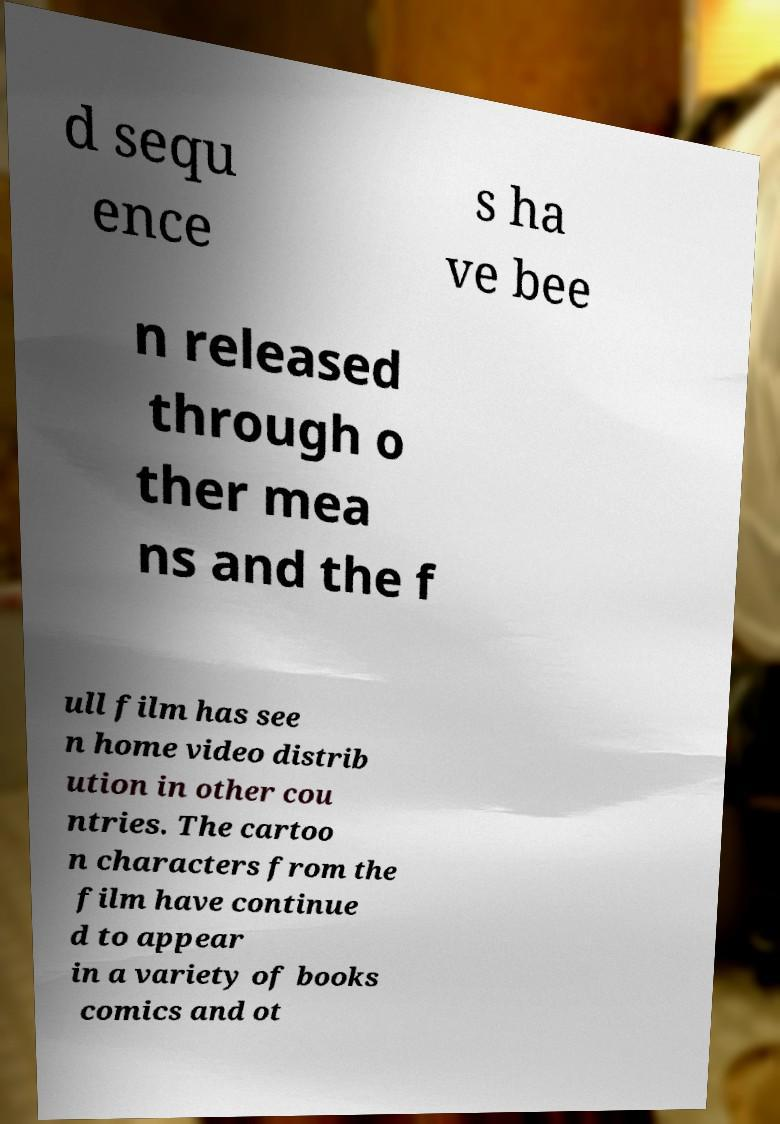I need the written content from this picture converted into text. Can you do that? d sequ ence s ha ve bee n released through o ther mea ns and the f ull film has see n home video distrib ution in other cou ntries. The cartoo n characters from the film have continue d to appear in a variety of books comics and ot 